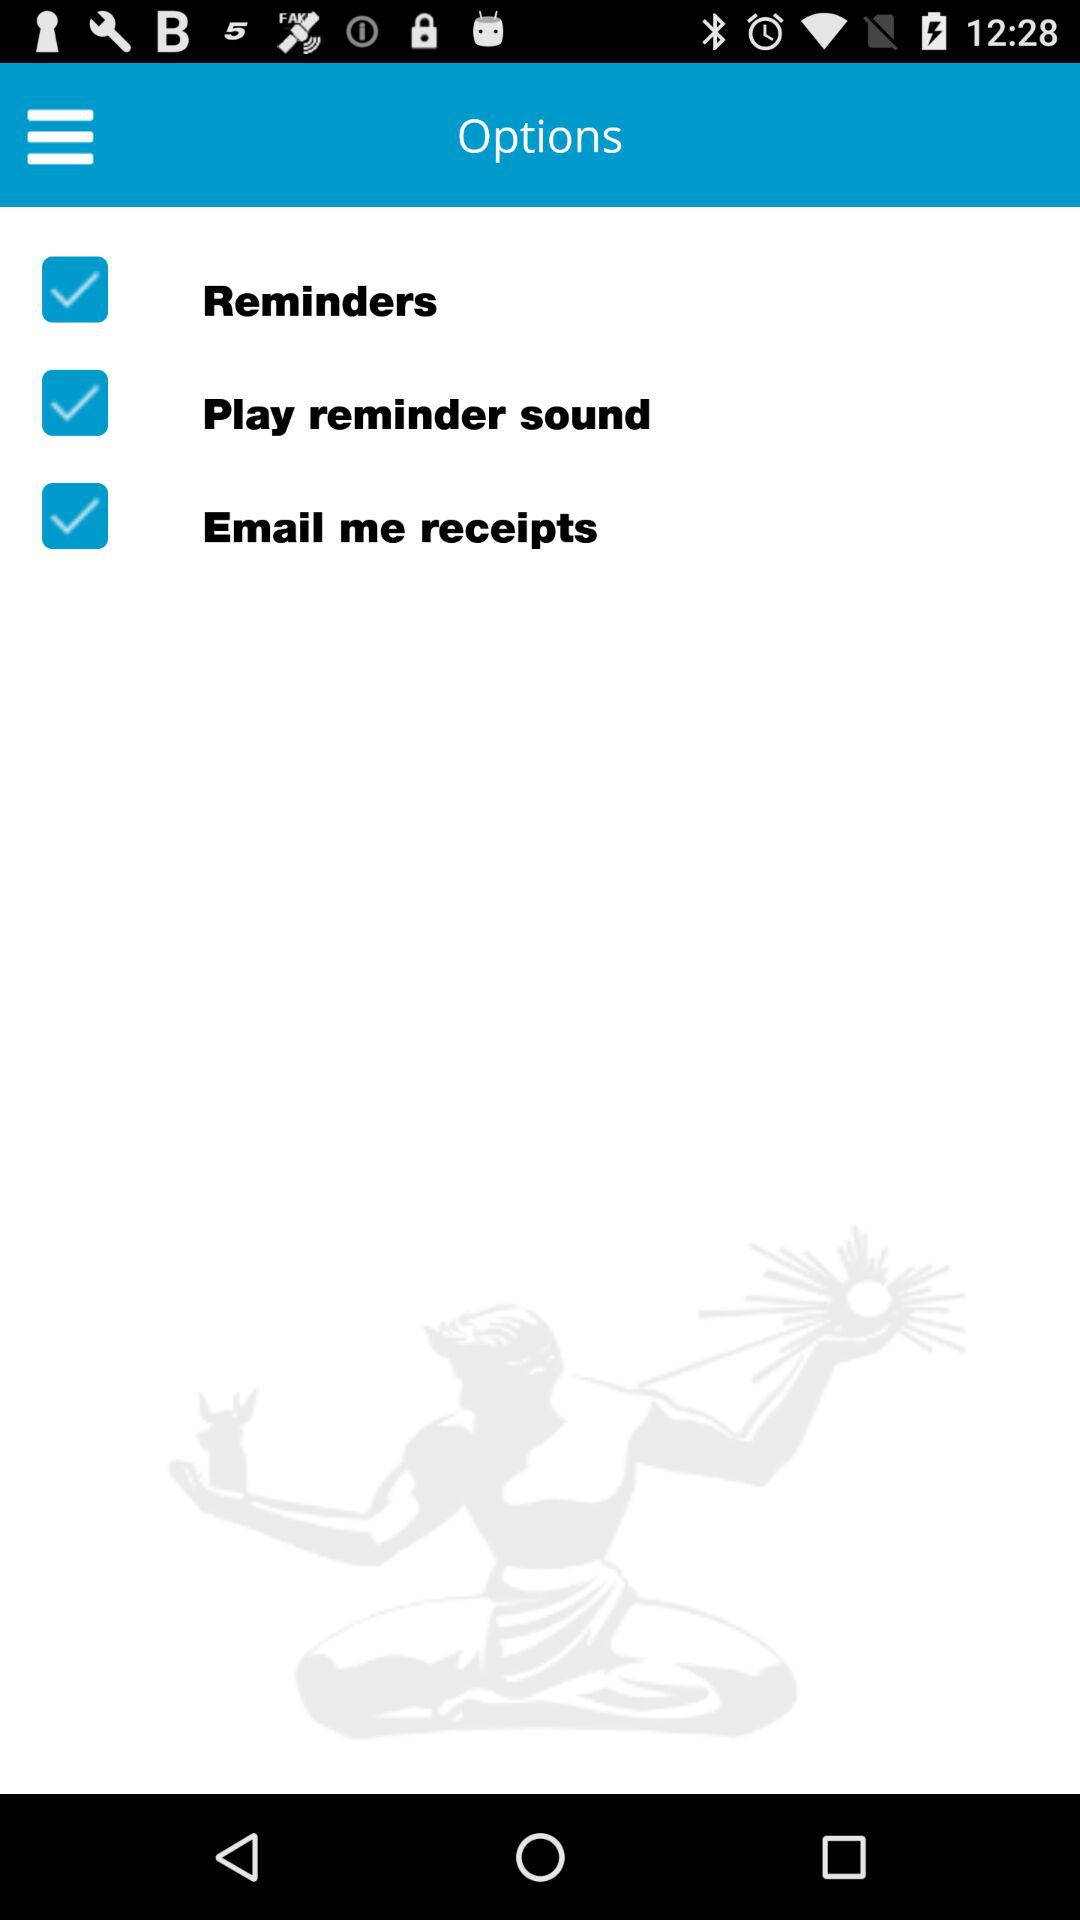What is the status of "Reminders"? The status is "on". 